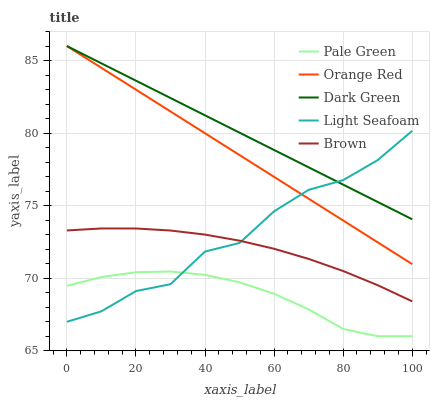Does Pale Green have the minimum area under the curve?
Answer yes or no. Yes. Does Dark Green have the maximum area under the curve?
Answer yes or no. Yes. Does Orange Red have the minimum area under the curve?
Answer yes or no. No. Does Orange Red have the maximum area under the curve?
Answer yes or no. No. Is Dark Green the smoothest?
Answer yes or no. Yes. Is Light Seafoam the roughest?
Answer yes or no. Yes. Is Pale Green the smoothest?
Answer yes or no. No. Is Pale Green the roughest?
Answer yes or no. No. Does Orange Red have the lowest value?
Answer yes or no. No. Does Dark Green have the highest value?
Answer yes or no. Yes. Does Pale Green have the highest value?
Answer yes or no. No. Is Brown less than Orange Red?
Answer yes or no. Yes. Is Dark Green greater than Pale Green?
Answer yes or no. Yes. Does Light Seafoam intersect Pale Green?
Answer yes or no. Yes. Is Light Seafoam less than Pale Green?
Answer yes or no. No. Is Light Seafoam greater than Pale Green?
Answer yes or no. No. Does Brown intersect Orange Red?
Answer yes or no. No. 